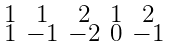<formula> <loc_0><loc_0><loc_500><loc_500>\begin{smallmatrix} 1 & 1 & 2 & 1 & 2 \\ 1 & - 1 & - 2 & 0 & - 1 \end{smallmatrix}</formula> 